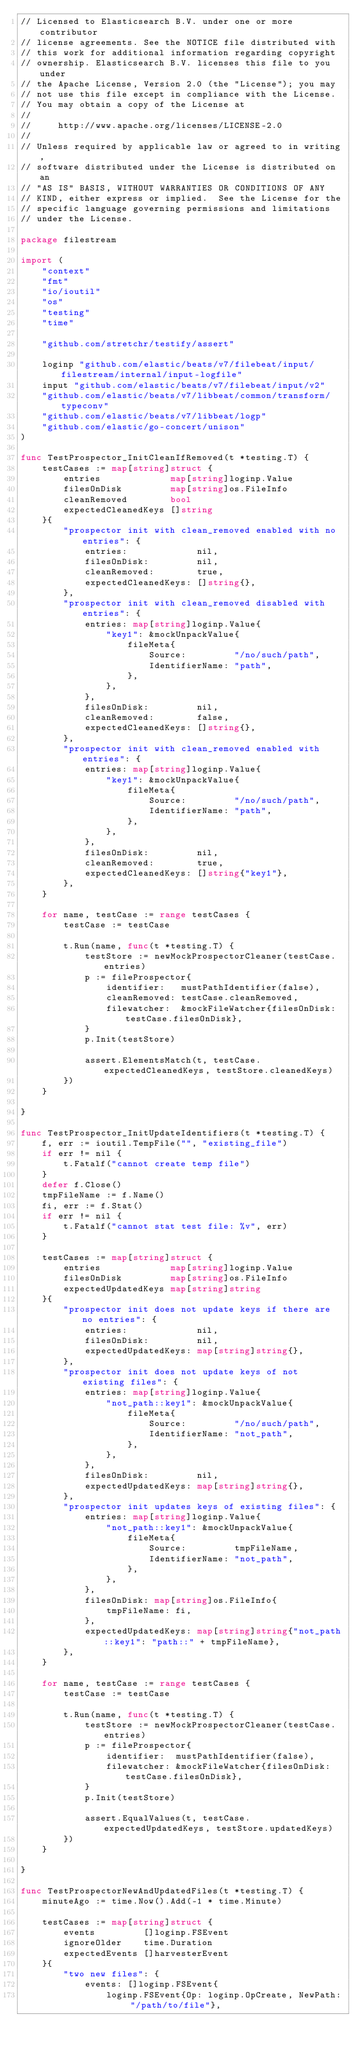Convert code to text. <code><loc_0><loc_0><loc_500><loc_500><_Go_>// Licensed to Elasticsearch B.V. under one or more contributor
// license agreements. See the NOTICE file distributed with
// this work for additional information regarding copyright
// ownership. Elasticsearch B.V. licenses this file to you under
// the Apache License, Version 2.0 (the "License"); you may
// not use this file except in compliance with the License.
// You may obtain a copy of the License at
//
//     http://www.apache.org/licenses/LICENSE-2.0
//
// Unless required by applicable law or agreed to in writing,
// software distributed under the License is distributed on an
// "AS IS" BASIS, WITHOUT WARRANTIES OR CONDITIONS OF ANY
// KIND, either express or implied.  See the License for the
// specific language governing permissions and limitations
// under the License.

package filestream

import (
	"context"
	"fmt"
	"io/ioutil"
	"os"
	"testing"
	"time"

	"github.com/stretchr/testify/assert"

	loginp "github.com/elastic/beats/v7/filebeat/input/filestream/internal/input-logfile"
	input "github.com/elastic/beats/v7/filebeat/input/v2"
	"github.com/elastic/beats/v7/libbeat/common/transform/typeconv"
	"github.com/elastic/beats/v7/libbeat/logp"
	"github.com/elastic/go-concert/unison"
)

func TestProspector_InitCleanIfRemoved(t *testing.T) {
	testCases := map[string]struct {
		entries             map[string]loginp.Value
		filesOnDisk         map[string]os.FileInfo
		cleanRemoved        bool
		expectedCleanedKeys []string
	}{
		"prospector init with clean_removed enabled with no entries": {
			entries:             nil,
			filesOnDisk:         nil,
			cleanRemoved:        true,
			expectedCleanedKeys: []string{},
		},
		"prospector init with clean_removed disabled with entries": {
			entries: map[string]loginp.Value{
				"key1": &mockUnpackValue{
					fileMeta{
						Source:         "/no/such/path",
						IdentifierName: "path",
					},
				},
			},
			filesOnDisk:         nil,
			cleanRemoved:        false,
			expectedCleanedKeys: []string{},
		},
		"prospector init with clean_removed enabled with entries": {
			entries: map[string]loginp.Value{
				"key1": &mockUnpackValue{
					fileMeta{
						Source:         "/no/such/path",
						IdentifierName: "path",
					},
				},
			},
			filesOnDisk:         nil,
			cleanRemoved:        true,
			expectedCleanedKeys: []string{"key1"},
		},
	}

	for name, testCase := range testCases {
		testCase := testCase

		t.Run(name, func(t *testing.T) {
			testStore := newMockProspectorCleaner(testCase.entries)
			p := fileProspector{
				identifier:   mustPathIdentifier(false),
				cleanRemoved: testCase.cleanRemoved,
				filewatcher:  &mockFileWatcher{filesOnDisk: testCase.filesOnDisk},
			}
			p.Init(testStore)

			assert.ElementsMatch(t, testCase.expectedCleanedKeys, testStore.cleanedKeys)
		})
	}

}

func TestProspector_InitUpdateIdentifiers(t *testing.T) {
	f, err := ioutil.TempFile("", "existing_file")
	if err != nil {
		t.Fatalf("cannot create temp file")
	}
	defer f.Close()
	tmpFileName := f.Name()
	fi, err := f.Stat()
	if err != nil {
		t.Fatalf("cannot stat test file: %v", err)
	}

	testCases := map[string]struct {
		entries             map[string]loginp.Value
		filesOnDisk         map[string]os.FileInfo
		expectedUpdatedKeys map[string]string
	}{
		"prospector init does not update keys if there are no entries": {
			entries:             nil,
			filesOnDisk:         nil,
			expectedUpdatedKeys: map[string]string{},
		},
		"prospector init does not update keys of not existing files": {
			entries: map[string]loginp.Value{
				"not_path::key1": &mockUnpackValue{
					fileMeta{
						Source:         "/no/such/path",
						IdentifierName: "not_path",
					},
				},
			},
			filesOnDisk:         nil,
			expectedUpdatedKeys: map[string]string{},
		},
		"prospector init updates keys of existing files": {
			entries: map[string]loginp.Value{
				"not_path::key1": &mockUnpackValue{
					fileMeta{
						Source:         tmpFileName,
						IdentifierName: "not_path",
					},
				},
			},
			filesOnDisk: map[string]os.FileInfo{
				tmpFileName: fi,
			},
			expectedUpdatedKeys: map[string]string{"not_path::key1": "path::" + tmpFileName},
		},
	}

	for name, testCase := range testCases {
		testCase := testCase

		t.Run(name, func(t *testing.T) {
			testStore := newMockProspectorCleaner(testCase.entries)
			p := fileProspector{
				identifier:  mustPathIdentifier(false),
				filewatcher: &mockFileWatcher{filesOnDisk: testCase.filesOnDisk},
			}
			p.Init(testStore)

			assert.EqualValues(t, testCase.expectedUpdatedKeys, testStore.updatedKeys)
		})
	}

}

func TestProspectorNewAndUpdatedFiles(t *testing.T) {
	minuteAgo := time.Now().Add(-1 * time.Minute)

	testCases := map[string]struct {
		events         []loginp.FSEvent
		ignoreOlder    time.Duration
		expectedEvents []harvesterEvent
	}{
		"two new files": {
			events: []loginp.FSEvent{
				loginp.FSEvent{Op: loginp.OpCreate, NewPath: "/path/to/file"},</code> 